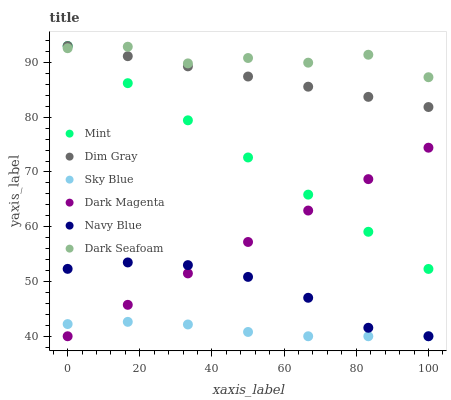Does Sky Blue have the minimum area under the curve?
Answer yes or no. Yes. Does Dark Seafoam have the maximum area under the curve?
Answer yes or no. Yes. Does Dark Magenta have the minimum area under the curve?
Answer yes or no. No. Does Dark Magenta have the maximum area under the curve?
Answer yes or no. No. Is Dark Magenta the smoothest?
Answer yes or no. Yes. Is Dark Seafoam the roughest?
Answer yes or no. Yes. Is Navy Blue the smoothest?
Answer yes or no. No. Is Navy Blue the roughest?
Answer yes or no. No. Does Dark Magenta have the lowest value?
Answer yes or no. Yes. Does Dark Seafoam have the lowest value?
Answer yes or no. No. Does Mint have the highest value?
Answer yes or no. Yes. Does Dark Magenta have the highest value?
Answer yes or no. No. Is Dark Magenta less than Dim Gray?
Answer yes or no. Yes. Is Dim Gray greater than Navy Blue?
Answer yes or no. Yes. Does Mint intersect Dark Seafoam?
Answer yes or no. Yes. Is Mint less than Dark Seafoam?
Answer yes or no. No. Is Mint greater than Dark Seafoam?
Answer yes or no. No. Does Dark Magenta intersect Dim Gray?
Answer yes or no. No. 